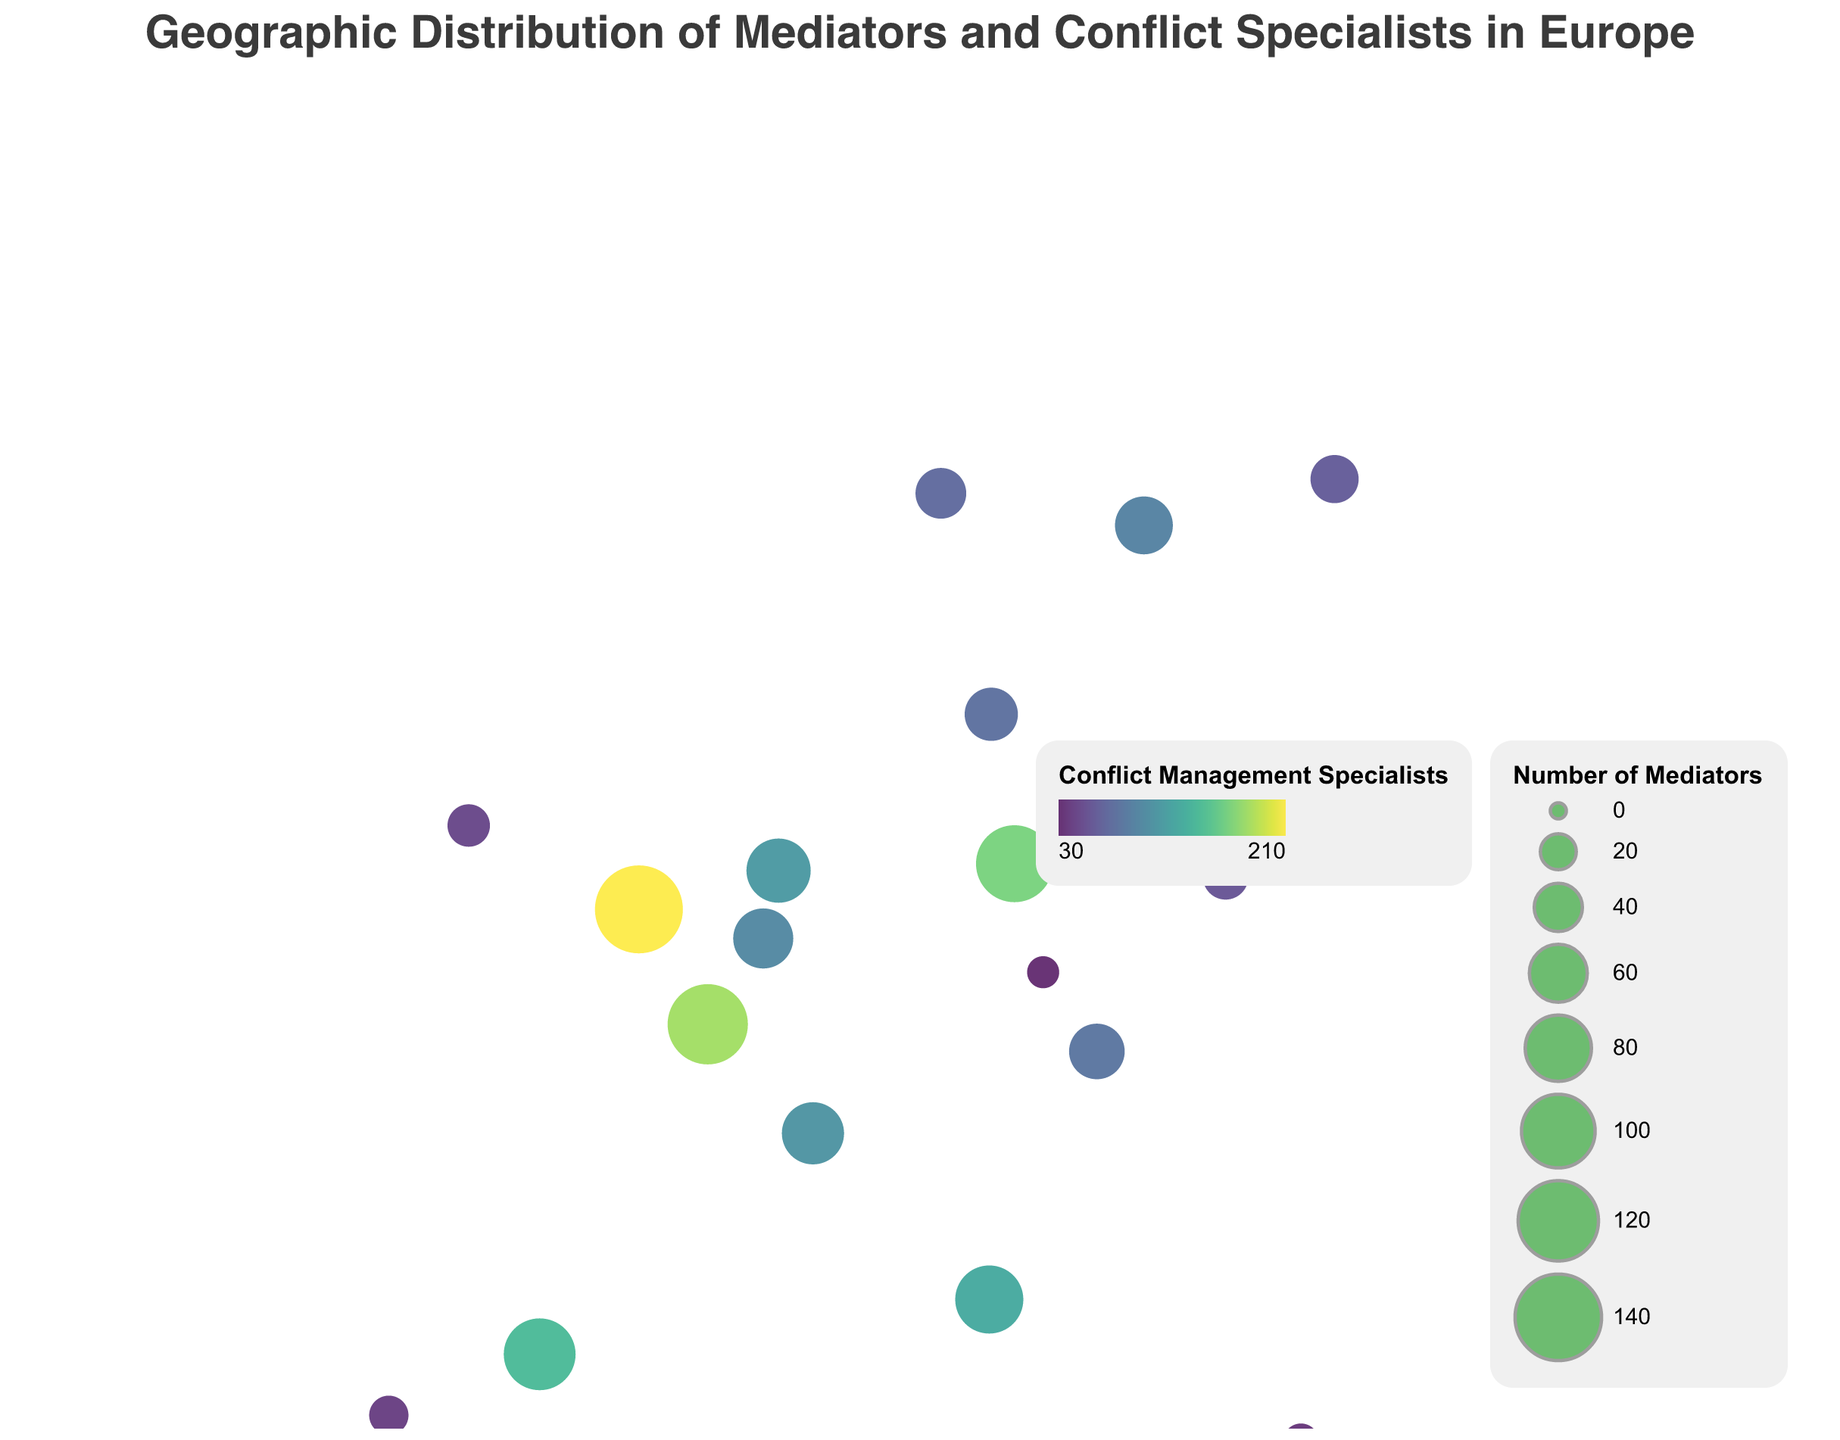What is the title of the figure? The title is displayed at the top of the figure, indicating the overall subject of the map.
Answer: Geographic Distribution of Mediators and Conflict Specialists in Europe Which country has the highest number of mediators? By examining the circle sizes on the map, the largest circle corresponds to the United Kingdom, specifically London.
Answer: United Kingdom What color scheme is used to represent Conflict Management Specialists? The color scheme used to depict the number of Conflict Management Specialists is 'viridis,' which progresses from darker to lighter shades.
Answer: viridis Which city has the most Conflict Management Specialists? The tooltip information reveals that London has the highest number of Conflict Management Specialists, with a count of 210.
Answer: London How many countries are represented on the map? By counting the number of distinct geographic locations on the map, you'll find there are a total of 17 countries listed.
Answer: 17 What is the median number of mediators across all cities? Arrange the number of Mediators in ascending order: 15, 20, 25, 30, 35, 40, 45, 50, 55, 60, 65, 70, 75, 85, 95, 110, 120, 145. The middle value is 55 in Vienna.
Answer: 55 Which country has more Conflict Management Specialists, France or Germany? Compare the number of Conflict Management Specialists for both countries: France has 180, whereas Germany has 165. France has more.
Answer: France What is the ratio of Mediators to Conflict Management Specialists in Rome? The ratio is found by dividing the number of Mediators by the number of Conflict Management Specialists in Rome: 85/125 = 0.68.
Answer: 0.68 Which city has both the smallest number of mediators and conflict management specialists? Prague has the smallest number of mediators (15) and conflict management specialists (30), as indicated by the size and color of the circle.
Answer: Prague Is there any country where the number of mediators is greater than the number of conflict management specialists? Upon examination, there is no country on the map where the number of mediators exceeds the number of conflict management specialists.
Answer: No 